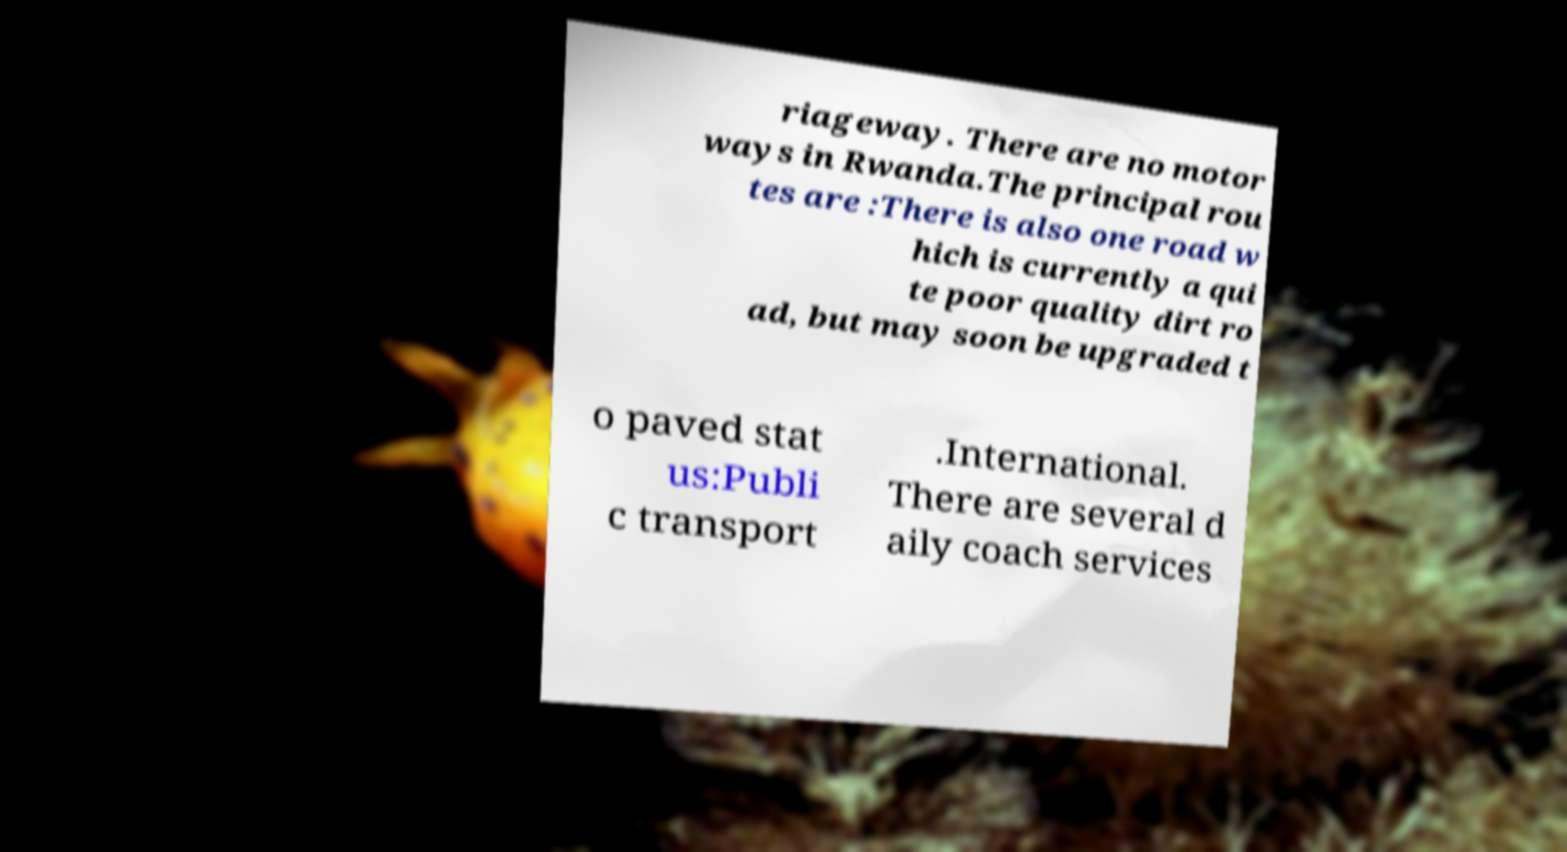I need the written content from this picture converted into text. Can you do that? riageway. There are no motor ways in Rwanda.The principal rou tes are :There is also one road w hich is currently a qui te poor quality dirt ro ad, but may soon be upgraded t o paved stat us:Publi c transport .International. There are several d aily coach services 